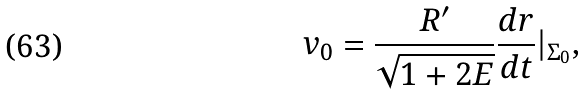<formula> <loc_0><loc_0><loc_500><loc_500>v _ { 0 } = \frac { R ^ { \prime } } { \sqrt { 1 + 2 E } } \frac { d r } { d t } | _ { \Sigma _ { 0 } } ,</formula> 